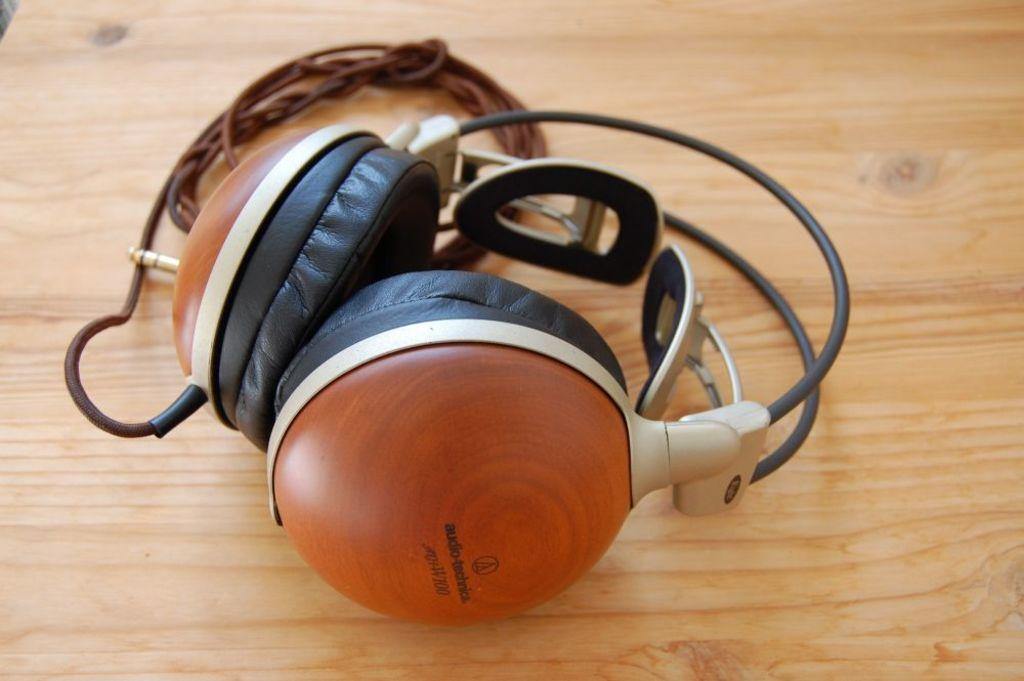What is placed on the table in the image? There is a headset placed on a table. What type of destruction can be seen happening to the headset in the image? There is no destruction happening to the headset in the image; it is simply placed on a table. 